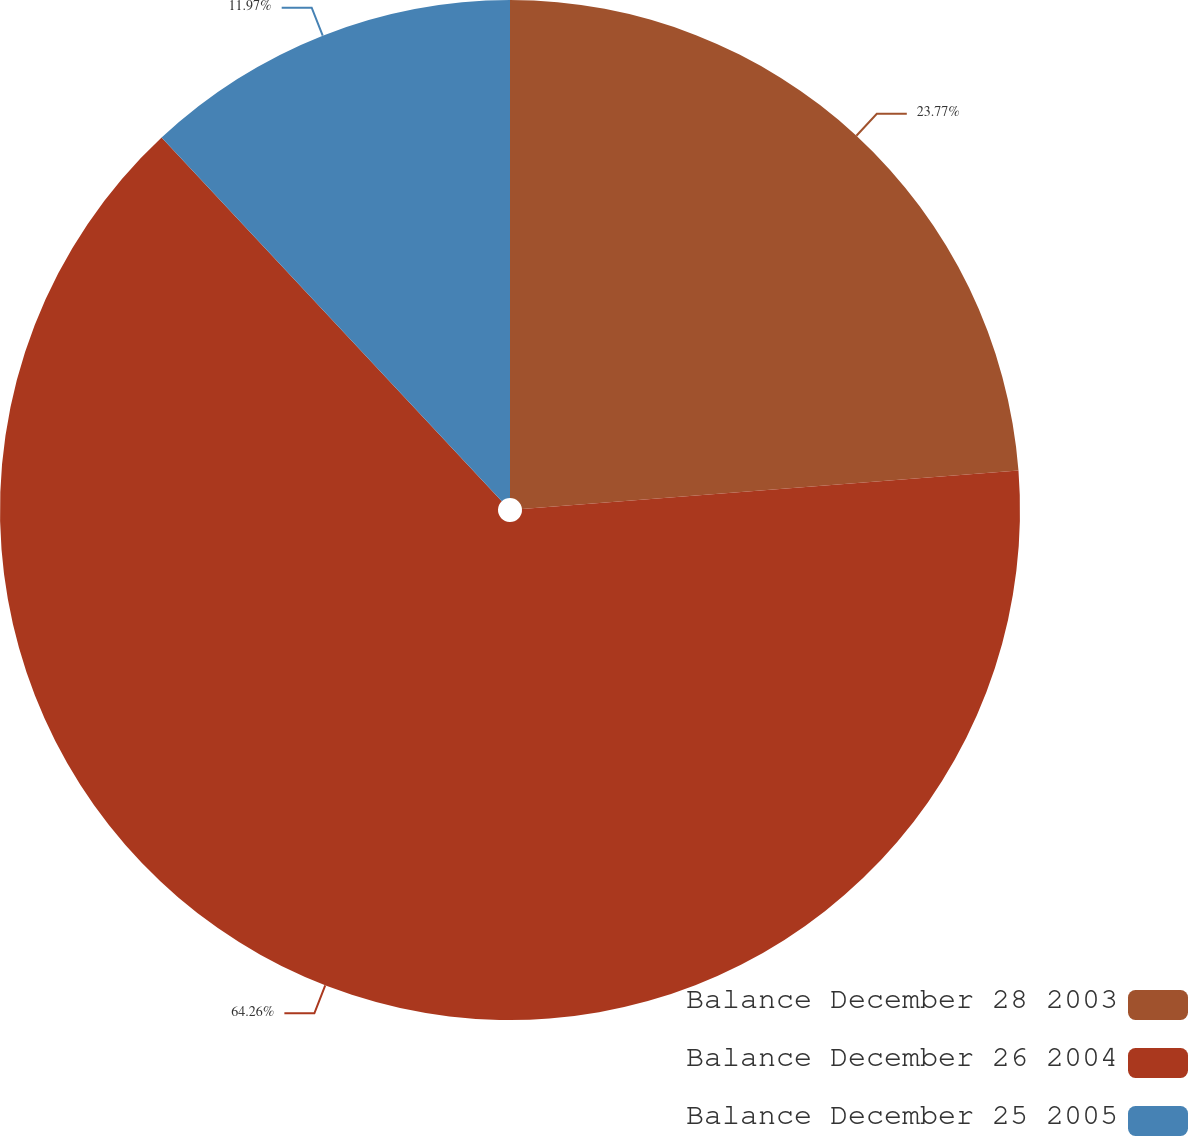<chart> <loc_0><loc_0><loc_500><loc_500><pie_chart><fcel>Balance December 28 2003<fcel>Balance December 26 2004<fcel>Balance December 25 2005<nl><fcel>23.77%<fcel>64.26%<fcel>11.97%<nl></chart> 